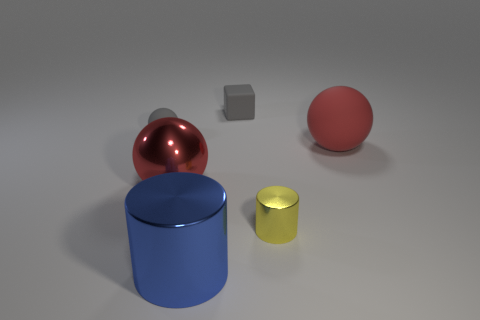Is the color of the matte object left of the gray matte block the same as the small matte block?
Offer a terse response. Yes. What number of big red spheres are behind the red ball that is to the left of the gray matte cube behind the blue thing?
Provide a short and direct response. 1. How many blue metallic cylinders are on the left side of the tiny cylinder?
Ensure brevity in your answer.  1. There is a big object that is the same shape as the small yellow shiny thing; what color is it?
Ensure brevity in your answer.  Blue. There is a big object that is behind the small shiny cylinder and to the left of the small yellow shiny cylinder; what is its material?
Offer a terse response. Metal. There is a gray matte thing that is in front of the rubber cube; does it have the same size as the blue shiny cylinder?
Provide a short and direct response. No. What is the gray sphere made of?
Give a very brief answer. Rubber. The object right of the tiny shiny object is what color?
Make the answer very short. Red. What number of large things are either gray cubes or red things?
Give a very brief answer. 2. There is a matte thing that is in front of the tiny sphere; is it the same color as the shiny object that is left of the big blue shiny cylinder?
Your answer should be compact. Yes. 